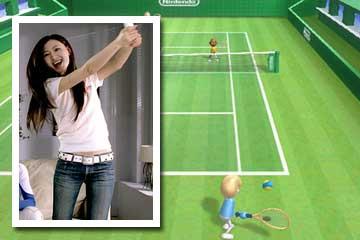Is the lady smiling?
Give a very brief answer. Yes. Which animated character in the video does the lady in the white shirt likely represent?
Give a very brief answer. Blue one. What sport is being represented?
Quick response, please. Tennis. 